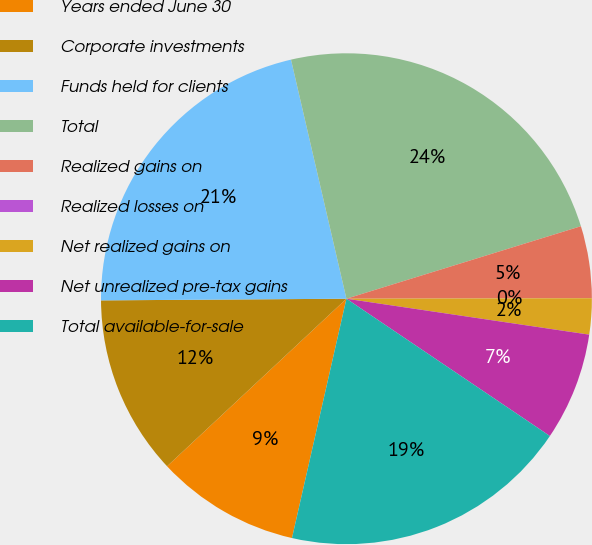<chart> <loc_0><loc_0><loc_500><loc_500><pie_chart><fcel>Years ended June 30<fcel>Corporate investments<fcel>Funds held for clients<fcel>Total<fcel>Realized gains on<fcel>Realized losses on<fcel>Net realized gains on<fcel>Net unrealized pre-tax gains<fcel>Total available-for-sale<nl><fcel>9.48%<fcel>11.85%<fcel>21.48%<fcel>23.85%<fcel>4.74%<fcel>0.0%<fcel>2.37%<fcel>7.11%<fcel>19.11%<nl></chart> 